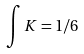Convert formula to latex. <formula><loc_0><loc_0><loc_500><loc_500>\int K = 1 / 6</formula> 